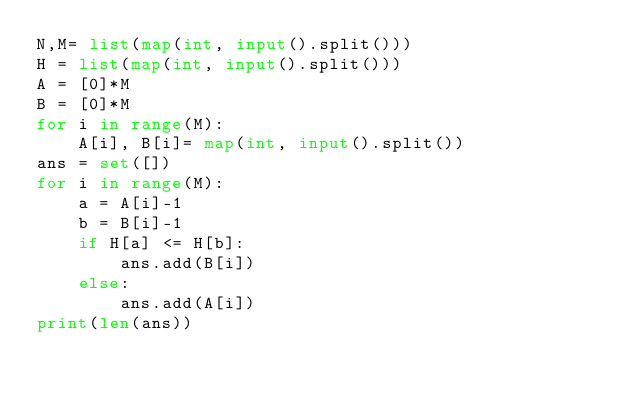Convert code to text. <code><loc_0><loc_0><loc_500><loc_500><_Python_>N,M= list(map(int, input().split())) 
H = list(map(int, input().split())) 
A = [0]*M
B = [0]*M
for i in range(M):
    A[i], B[i]= map(int, input().split())
ans = set([])
for i in range(M):
    a = A[i]-1
    b = B[i]-1
    if H[a] <= H[b]:
        ans.add(B[i])
    else:
        ans.add(A[i])
print(len(ans))</code> 